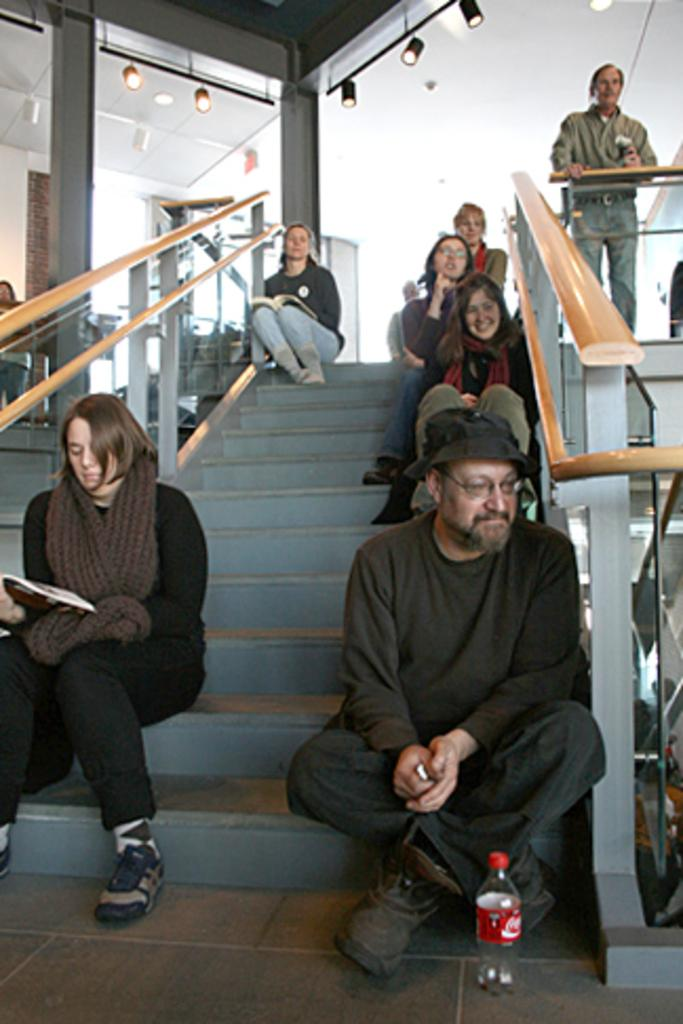What are the people in the image doing? The people in the image are sitting on the stairs in the center of the image. Can you describe the person on the right side of the image? There is a person standing on the right side of the image. What can be seen in the background of the image? There are lights and a wall visible in the background. What type of liquid is being used to fuel the letters in the image? There are no liquid or fuel elements, nor any letters present in the image. 